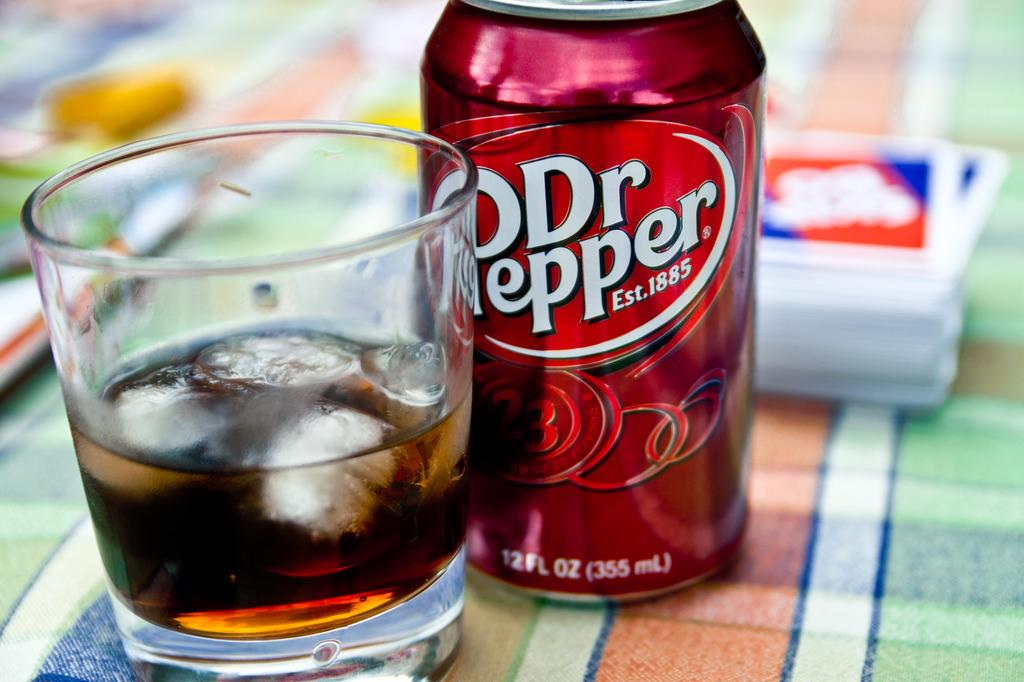<image>
Render a clear and concise summary of the photo. A can of Dr Pepper is on a colorful tablecloth next to a glass of the beverage with ice in it. 